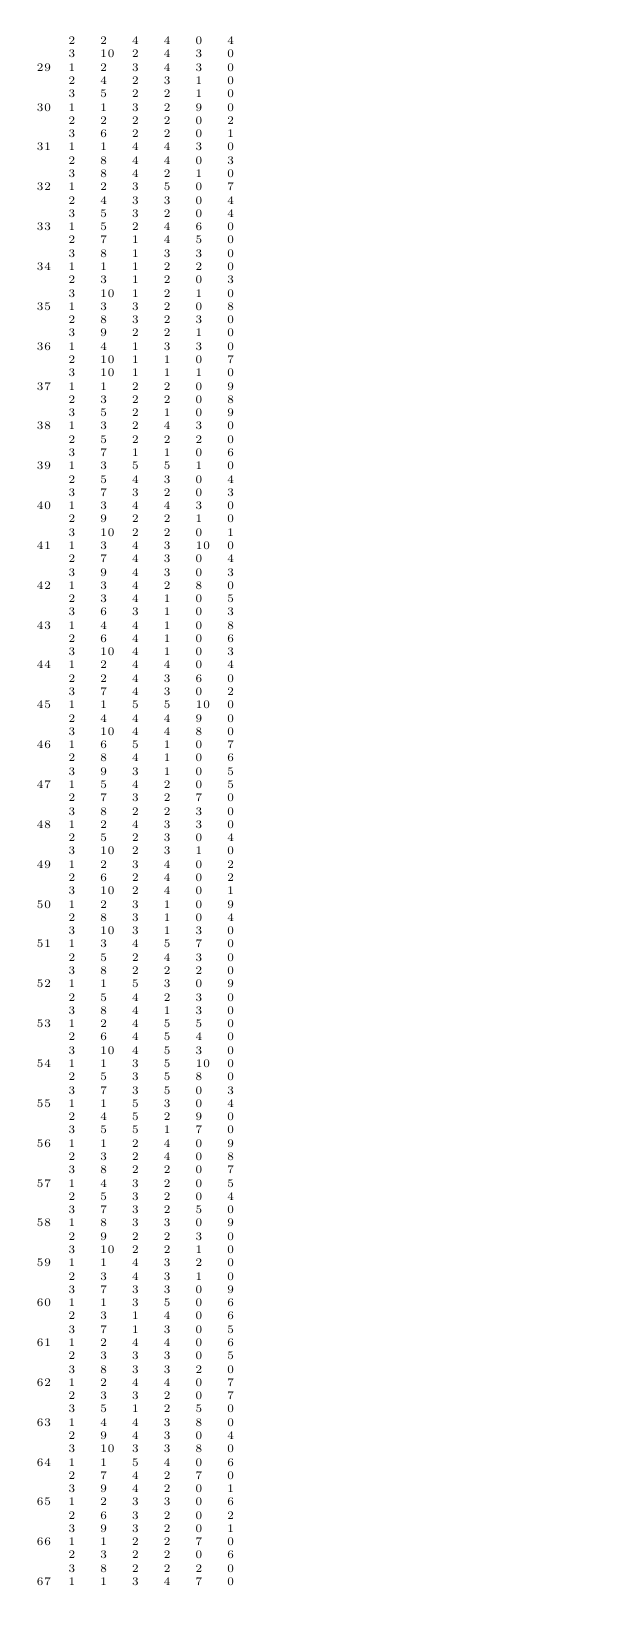Convert code to text. <code><loc_0><loc_0><loc_500><loc_500><_ObjectiveC_>	2	2	4	4	0	4	
	3	10	2	4	3	0	
29	1	2	3	4	3	0	
	2	4	2	3	1	0	
	3	5	2	2	1	0	
30	1	1	3	2	9	0	
	2	2	2	2	0	2	
	3	6	2	2	0	1	
31	1	1	4	4	3	0	
	2	8	4	4	0	3	
	3	8	4	2	1	0	
32	1	2	3	5	0	7	
	2	4	3	3	0	4	
	3	5	3	2	0	4	
33	1	5	2	4	6	0	
	2	7	1	4	5	0	
	3	8	1	3	3	0	
34	1	1	1	2	2	0	
	2	3	1	2	0	3	
	3	10	1	2	1	0	
35	1	3	3	2	0	8	
	2	8	3	2	3	0	
	3	9	2	2	1	0	
36	1	4	1	3	3	0	
	2	10	1	1	0	7	
	3	10	1	1	1	0	
37	1	1	2	2	0	9	
	2	3	2	2	0	8	
	3	5	2	1	0	9	
38	1	3	2	4	3	0	
	2	5	2	2	2	0	
	3	7	1	1	0	6	
39	1	3	5	5	1	0	
	2	5	4	3	0	4	
	3	7	3	2	0	3	
40	1	3	4	4	3	0	
	2	9	2	2	1	0	
	3	10	2	2	0	1	
41	1	3	4	3	10	0	
	2	7	4	3	0	4	
	3	9	4	3	0	3	
42	1	3	4	2	8	0	
	2	3	4	1	0	5	
	3	6	3	1	0	3	
43	1	4	4	1	0	8	
	2	6	4	1	0	6	
	3	10	4	1	0	3	
44	1	2	4	4	0	4	
	2	2	4	3	6	0	
	3	7	4	3	0	2	
45	1	1	5	5	10	0	
	2	4	4	4	9	0	
	3	10	4	4	8	0	
46	1	6	5	1	0	7	
	2	8	4	1	0	6	
	3	9	3	1	0	5	
47	1	5	4	2	0	5	
	2	7	3	2	7	0	
	3	8	2	2	3	0	
48	1	2	4	3	3	0	
	2	5	2	3	0	4	
	3	10	2	3	1	0	
49	1	2	3	4	0	2	
	2	6	2	4	0	2	
	3	10	2	4	0	1	
50	1	2	3	1	0	9	
	2	8	3	1	0	4	
	3	10	3	1	3	0	
51	1	3	4	5	7	0	
	2	5	2	4	3	0	
	3	8	2	2	2	0	
52	1	1	5	3	0	9	
	2	5	4	2	3	0	
	3	8	4	1	3	0	
53	1	2	4	5	5	0	
	2	6	4	5	4	0	
	3	10	4	5	3	0	
54	1	1	3	5	10	0	
	2	5	3	5	8	0	
	3	7	3	5	0	3	
55	1	1	5	3	0	4	
	2	4	5	2	9	0	
	3	5	5	1	7	0	
56	1	1	2	4	0	9	
	2	3	2	4	0	8	
	3	8	2	2	0	7	
57	1	4	3	2	0	5	
	2	5	3	2	0	4	
	3	7	3	2	5	0	
58	1	8	3	3	0	9	
	2	9	2	2	3	0	
	3	10	2	2	1	0	
59	1	1	4	3	2	0	
	2	3	4	3	1	0	
	3	7	3	3	0	9	
60	1	1	3	5	0	6	
	2	3	1	4	0	6	
	3	7	1	3	0	5	
61	1	2	4	4	0	6	
	2	3	3	3	0	5	
	3	8	3	3	2	0	
62	1	2	4	4	0	7	
	2	3	3	2	0	7	
	3	5	1	2	5	0	
63	1	4	4	3	8	0	
	2	9	4	3	0	4	
	3	10	3	3	8	0	
64	1	1	5	4	0	6	
	2	7	4	2	7	0	
	3	9	4	2	0	1	
65	1	2	3	3	0	6	
	2	6	3	2	0	2	
	3	9	3	2	0	1	
66	1	1	2	2	7	0	
	2	3	2	2	0	6	
	3	8	2	2	2	0	
67	1	1	3	4	7	0	</code> 